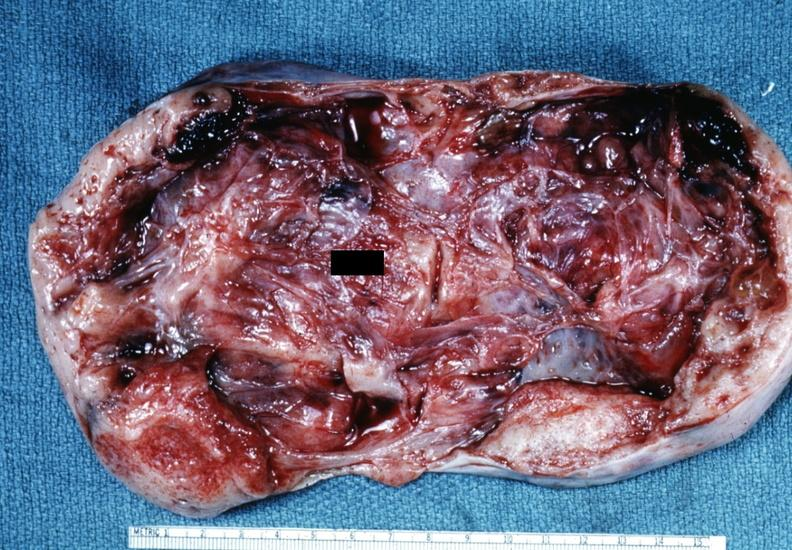what is present?
Answer the question using a single word or phrase. Ovary 